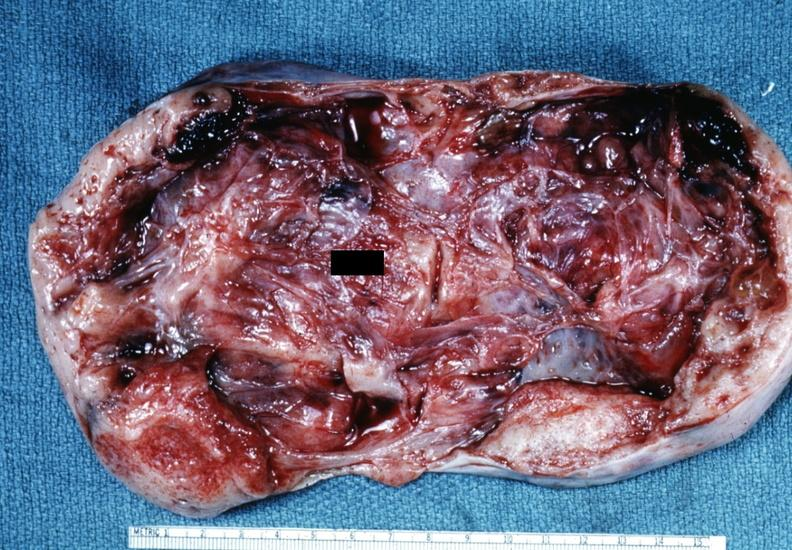what is present?
Answer the question using a single word or phrase. Ovary 